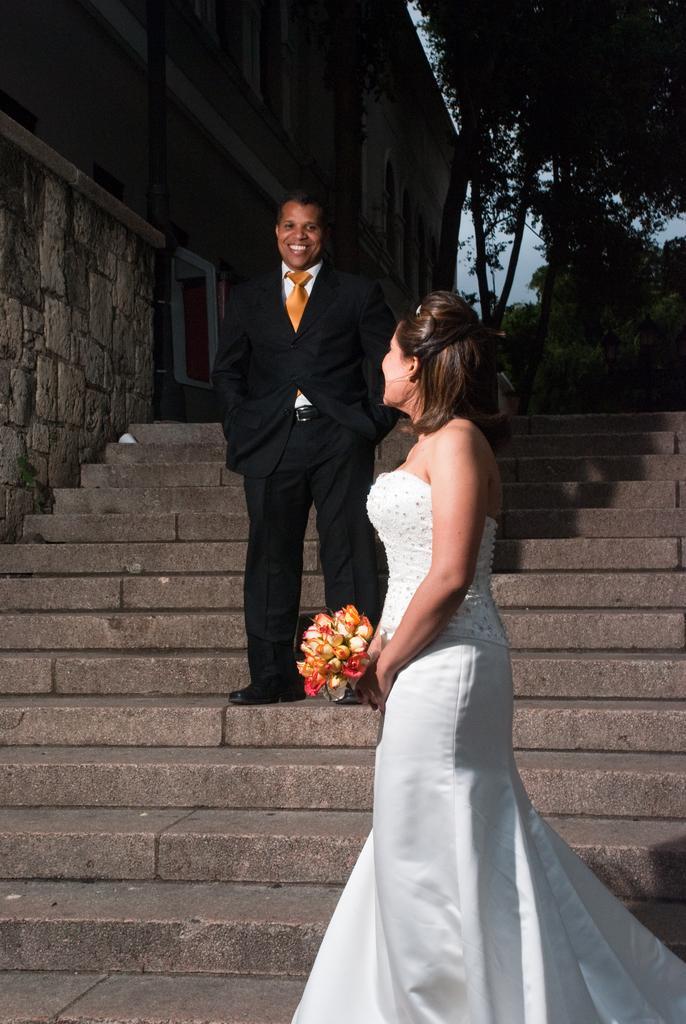Can you describe this image briefly? In the center of the image there are two people on the staircase. In the background of the image there are trees. To the left side of the image there is a building. 